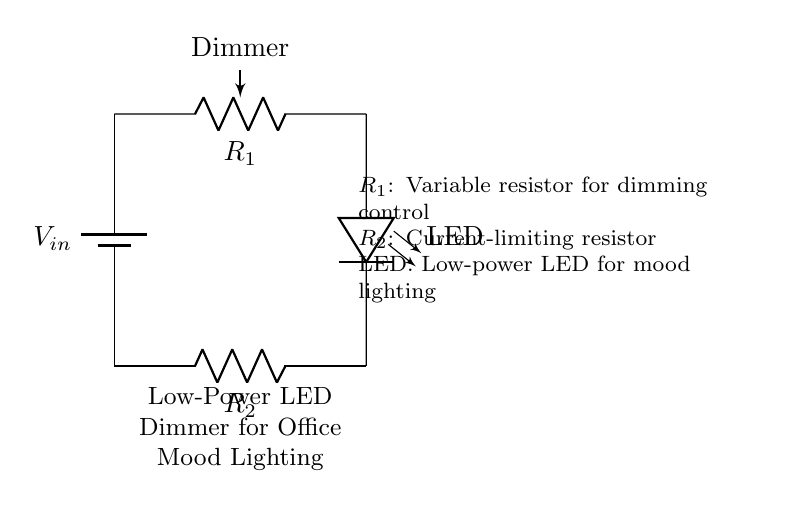What is the function of the potentiometer in this circuit? The potentiometer operates as a dimmer, allowing the user to adjust the brightness of the LED by varying the resistance.
Answer: dimmer What is the purpose of the current-limiting resistor? The current-limiting resistor is used to prevent excessive current from flowing through the LED, ensuring its safe operation and prolonging its lifespan.
Answer: current-limiting How many components are in this circuit? Counting the battery, potentiometer, LED, and resistor, there are four components in total in this circuit.
Answer: four What type of lighting does this circuit provide? The circuit is designed to provide mood lighting, which is typically softer and more adjustable than regular lighting to create a specific atmosphere.
Answer: mood lighting What happens if the potentiometer is set to the minimum resistance? Setting the potentiometer to the minimum resistance allows maximum current to pass through the LED, resulting in the brightest output.
Answer: maximum brightness What is the voltage source in this circuit? The voltage source is represented by the battery, which supplies the necessary electrical energy to power the LED and control its brightness.
Answer: battery What is the connection of the LED in relation to the other components? The LED is connected in series with the potentiometer and the current-limiting resistor, allowing current to flow through it when powered.
Answer: series connection 